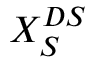<formula> <loc_0><loc_0><loc_500><loc_500>X _ { S } ^ { D S }</formula> 